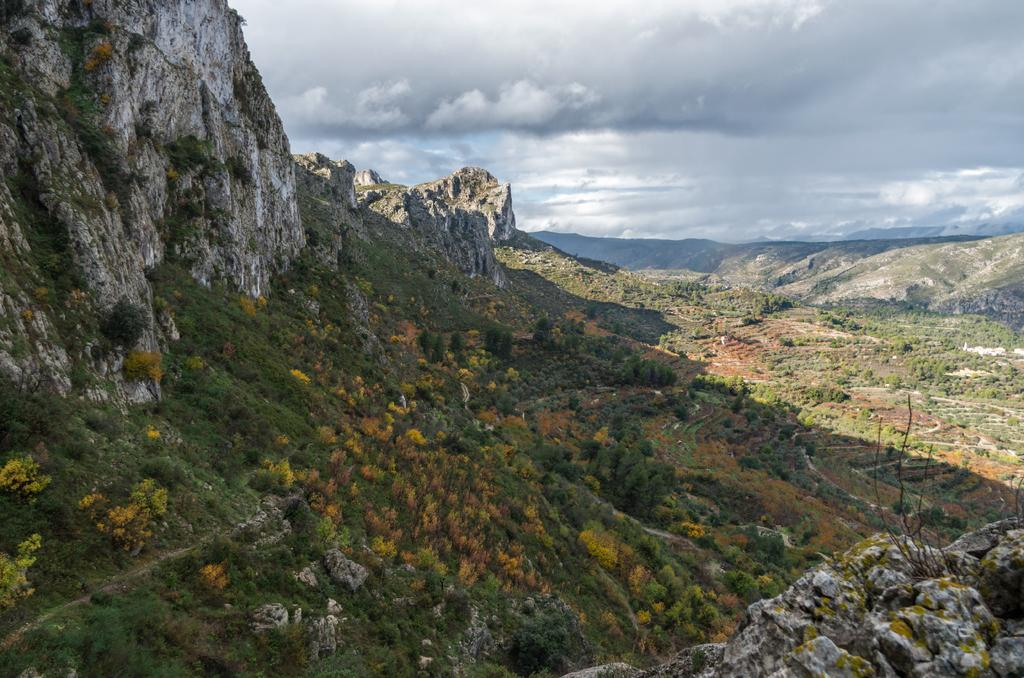What type of vegetation is present in the image? There is grass and plants in the image. What can be seen in the background of the image? There are mountains, clouds, and the sky visible in the background of the image. What type of zinc is being used to play volleyball in the image? There is no zinc or volleyball present in the image. Can you see the thumb of the person taking the picture in the image? There is no person or thumb visible in the image. 